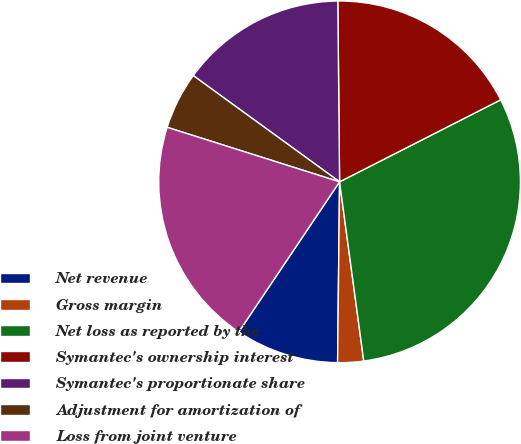Convert chart to OTSL. <chart><loc_0><loc_0><loc_500><loc_500><pie_chart><fcel>Net revenue<fcel>Gross margin<fcel>Net loss as reported by the<fcel>Symantec's ownership interest<fcel>Symantec's proportionate share<fcel>Adjustment for amortization of<fcel>Loss from joint venture<nl><fcel>9.24%<fcel>2.31%<fcel>30.36%<fcel>17.66%<fcel>14.85%<fcel>5.12%<fcel>20.46%<nl></chart> 